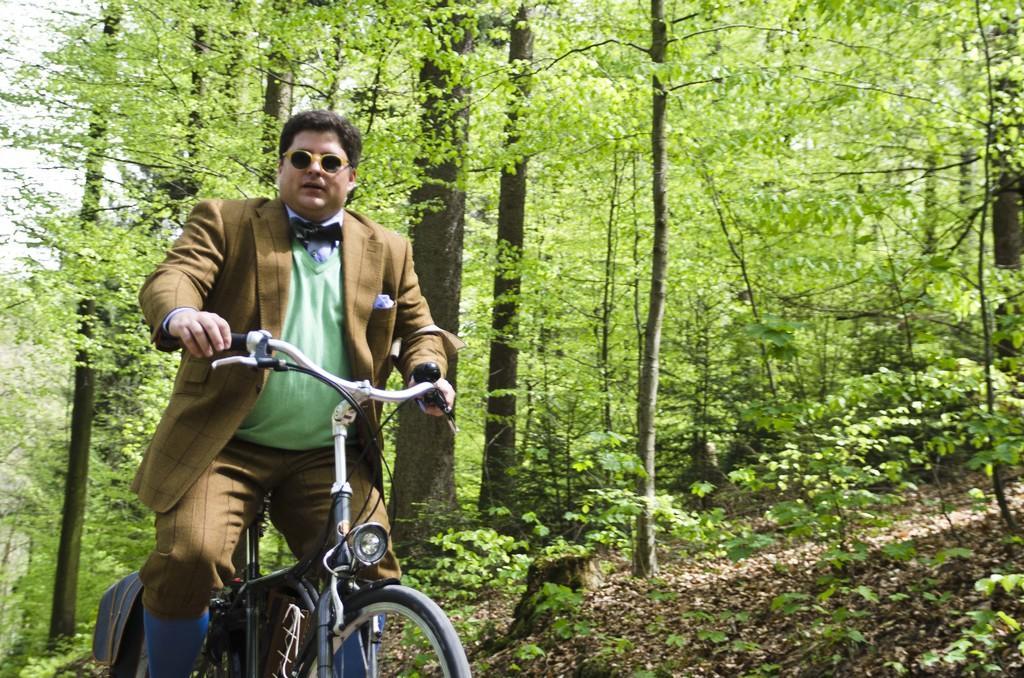Could you give a brief overview of what you see in this image? In this image I can see a man on his cycle, I can see he is wearing a shades. In the background I can see number of trees. 